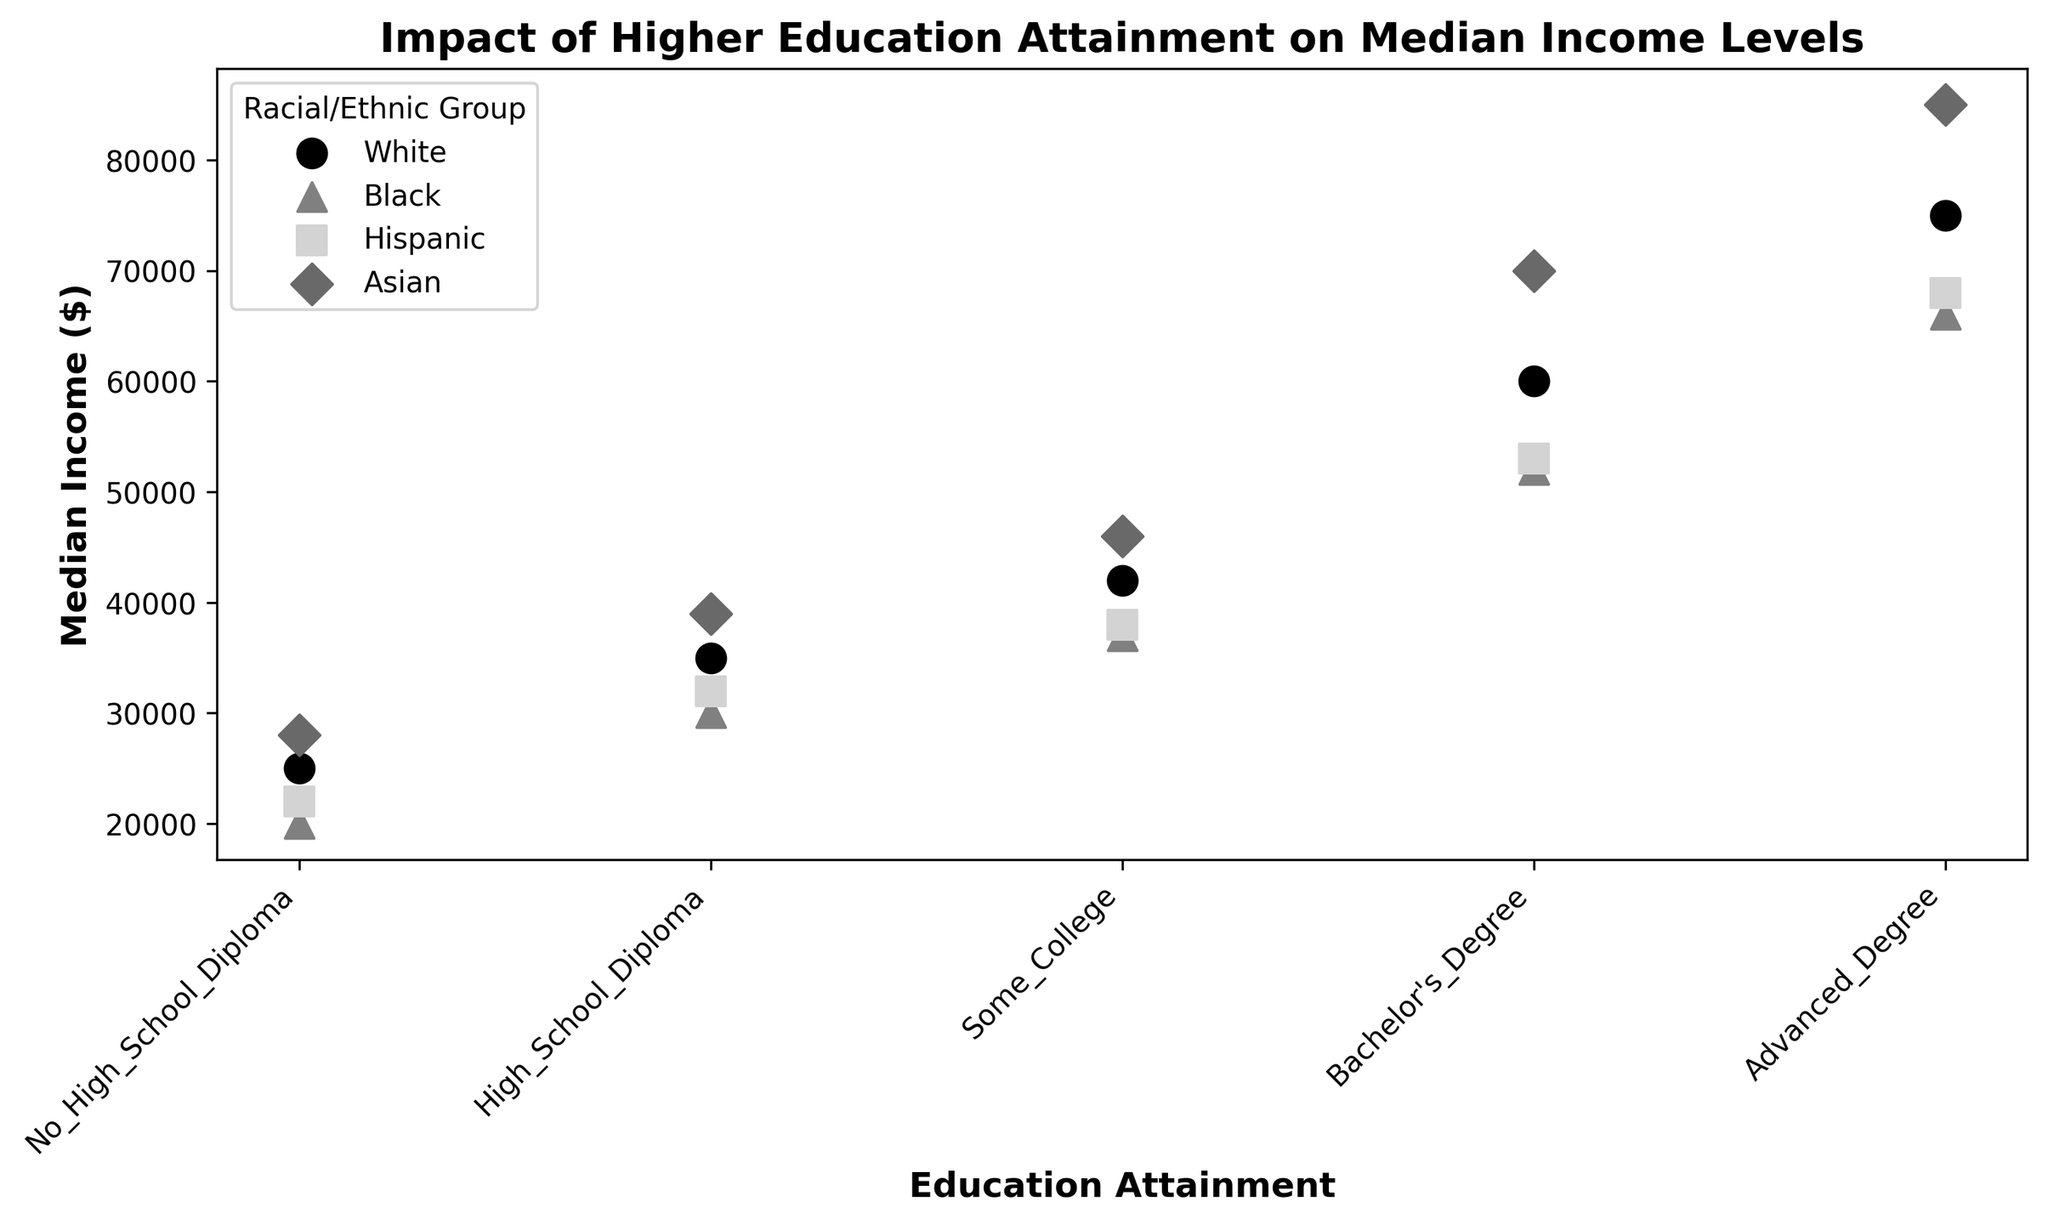What is the median income for individuals with a Bachelor's Degree in the White racial/ethnic group? Identify the point corresponding to the White racial/ethnic group and Bachelor's Degree on the scatter plot. The y-axis value is the median income for this category.
Answer: 60000 Which racial/ethnic group has the highest median income for individuals with Advanced Degrees? Find the highest point among the Advanced Degree category across all racial/ethnic groups by comparing their positions on the y-axis. The highest point corresponds to the racial/ethnic group with the highest median income.
Answer: Asian How does the median income for Hispanics with Some College education compare to Blacks with the same education level? Locate the points for "Some College" education for both Hispanics and Blacks on the scatter plot. Compare their positions on the y-axis to see which is higher.
Answer: Hispanic: 38000, Black: 37000 Which education attainment level shows the smallest difference in median income between White and Black individuals? Calculate the difference in median incomes between White and Black individuals for each education level by looking at the y-axis and finding the smallest difference.
Answer: Advanced Degree (9000) What is the median income difference between Asians and Hispanics with a Bachelor's Degree? Find the y-axis values for Asians and Hispanics with a Bachelor's Degree and subtract the Hispanic median income from the Asian median income.
Answer: 17000 Rank the racial/ethnic groups by median income for individuals with High School Diplomas from highest to lowest. Identify the y-axis positions of the points for each racial/ethnic group with a High School Diploma, then sort them from highest to lowest median income.
Answer: Asian, White, Hispanic, Black Compare the overall trend of median income changes with increasing education levels among the racial/ethnic groups. Observe the overall pattern or slope of the points for each racial/ethnic group as education levels increase from No High School Diploma to Advanced Degree.
Answer: Median income increases with higher education levels for all groups; Asians consistently have the highest, followed by Whites, Hispanics, and Blacks What is the median income for Black individuals with no high school diploma, and how does it compare to Hispanic individuals with the same education level? Identify the points representing Black and Hispanic individuals with no high school diploma on the scatter plot and compare their y-axis positions.
Answer: Black: 20000, Hispanic: 22000 What is the difference in median income between Whites with Some College and Asians with High School Diplomas? Locate the y-axis values for Whites with Some College and Asians with High School Diplomas and subtract the Asian median income from the White median income.
Answer: 3000 